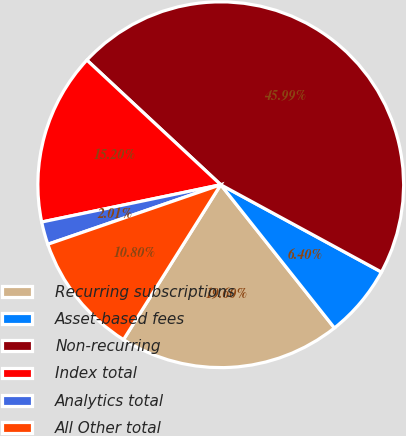<chart> <loc_0><loc_0><loc_500><loc_500><pie_chart><fcel>Recurring subscriptions<fcel>Asset-based fees<fcel>Non-recurring<fcel>Index total<fcel>Analytics total<fcel>All Other total<nl><fcel>19.6%<fcel>6.4%<fcel>45.99%<fcel>15.2%<fcel>2.01%<fcel>10.8%<nl></chart> 